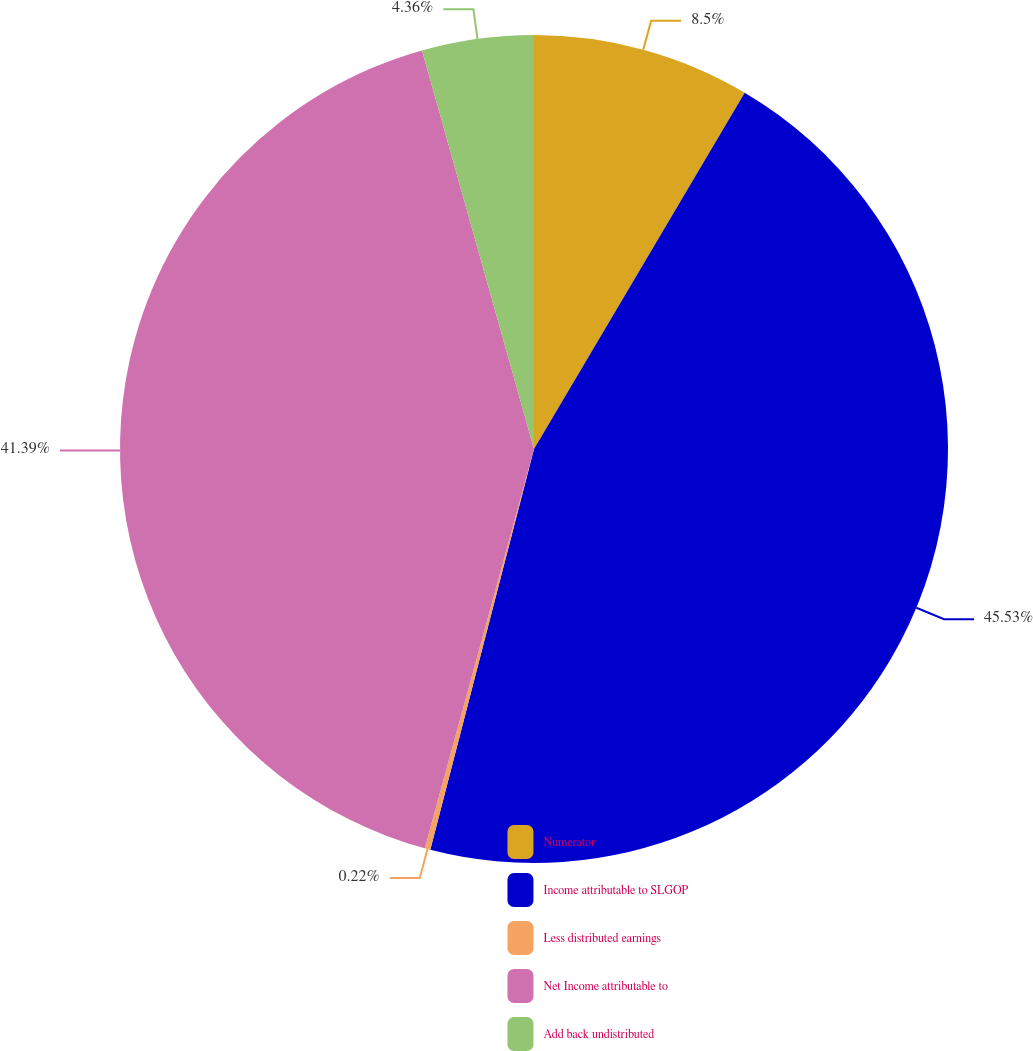<chart> <loc_0><loc_0><loc_500><loc_500><pie_chart><fcel>Numerator<fcel>Income attributable to SLGOP<fcel>Less distributed earnings<fcel>Net Income attributable to<fcel>Add back undistributed<nl><fcel>8.5%<fcel>45.54%<fcel>0.22%<fcel>41.4%<fcel>4.36%<nl></chart> 